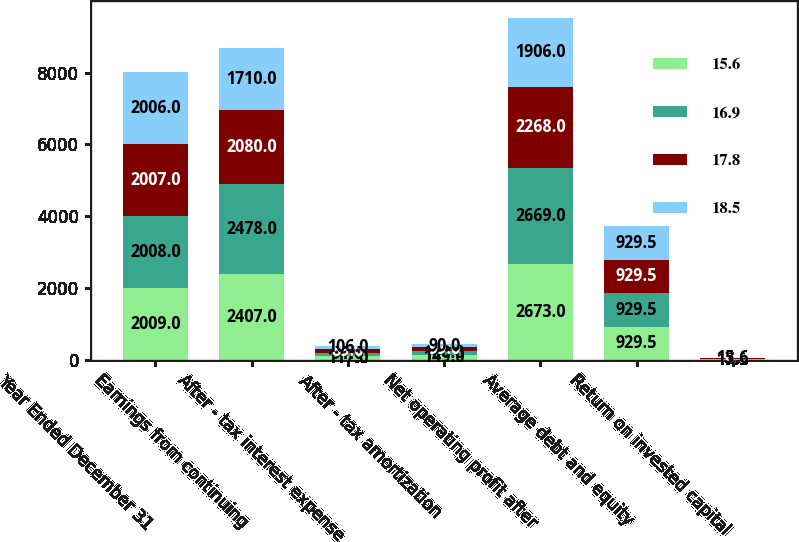Convert chart. <chart><loc_0><loc_0><loc_500><loc_500><stacked_bar_chart><ecel><fcel>Year Ended December 31<fcel>Earnings from continuing<fcel>After - tax interest expense<fcel>After - tax amortization<fcel>Net operating profit after<fcel>Average debt and equity<fcel>Return on invested capital<nl><fcel>15.6<fcel>2009<fcel>2407<fcel>117<fcel>149<fcel>2673<fcel>929.5<fcel>17.8<nl><fcel>16.9<fcel>2008<fcel>2478<fcel>91<fcel>100<fcel>2669<fcel>929.5<fcel>18.5<nl><fcel>17.8<fcel>2007<fcel>2080<fcel>89<fcel>99<fcel>2268<fcel>929.5<fcel>16.9<nl><fcel>18.5<fcel>2006<fcel>1710<fcel>106<fcel>90<fcel>1906<fcel>929.5<fcel>15.6<nl></chart> 